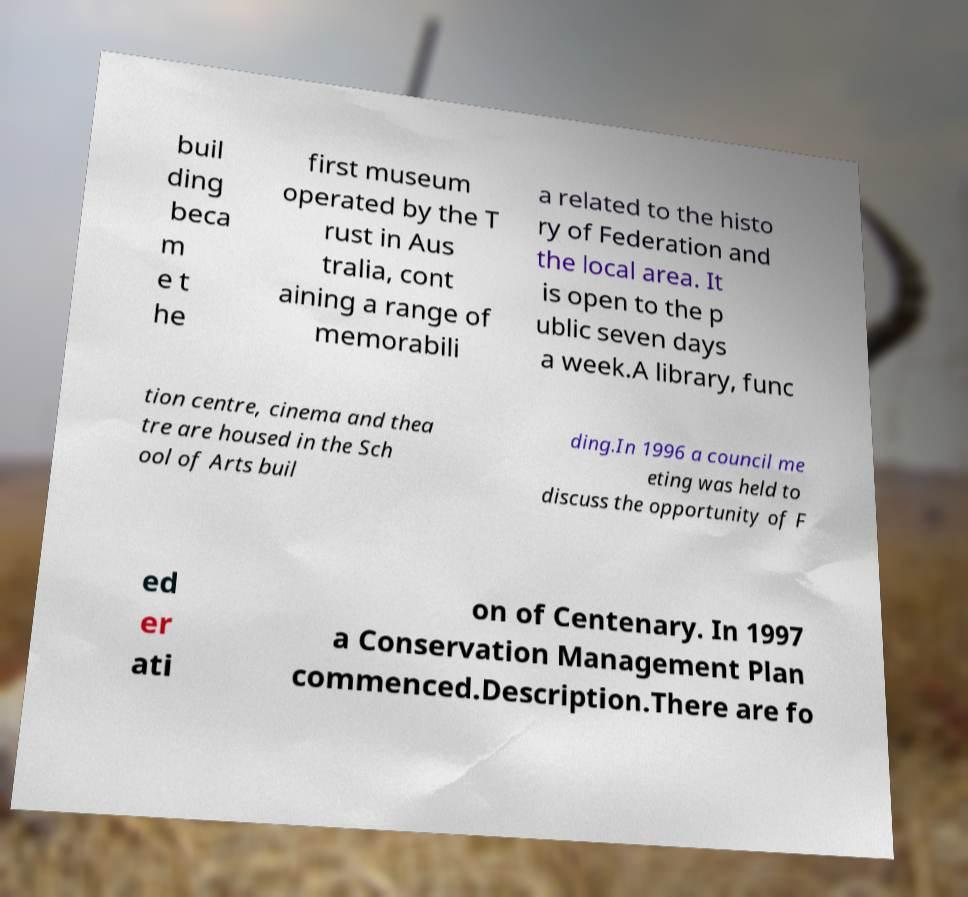Could you assist in decoding the text presented in this image and type it out clearly? buil ding beca m e t he first museum operated by the T rust in Aus tralia, cont aining a range of memorabili a related to the histo ry of Federation and the local area. It is open to the p ublic seven days a week.A library, func tion centre, cinema and thea tre are housed in the Sch ool of Arts buil ding.In 1996 a council me eting was held to discuss the opportunity of F ed er ati on of Centenary. In 1997 a Conservation Management Plan commenced.Description.There are fo 